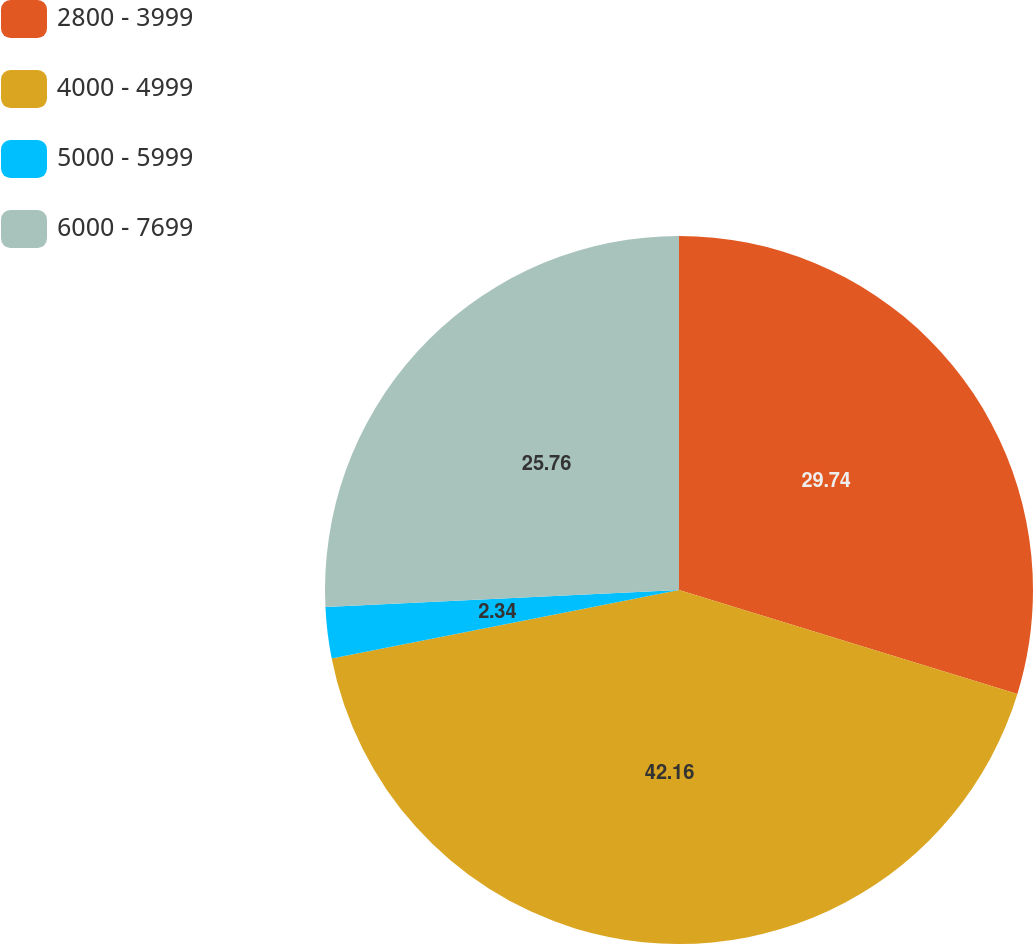<chart> <loc_0><loc_0><loc_500><loc_500><pie_chart><fcel>2800 - 3999<fcel>4000 - 4999<fcel>5000 - 5999<fcel>6000 - 7699<nl><fcel>29.74%<fcel>42.15%<fcel>2.34%<fcel>25.76%<nl></chart> 